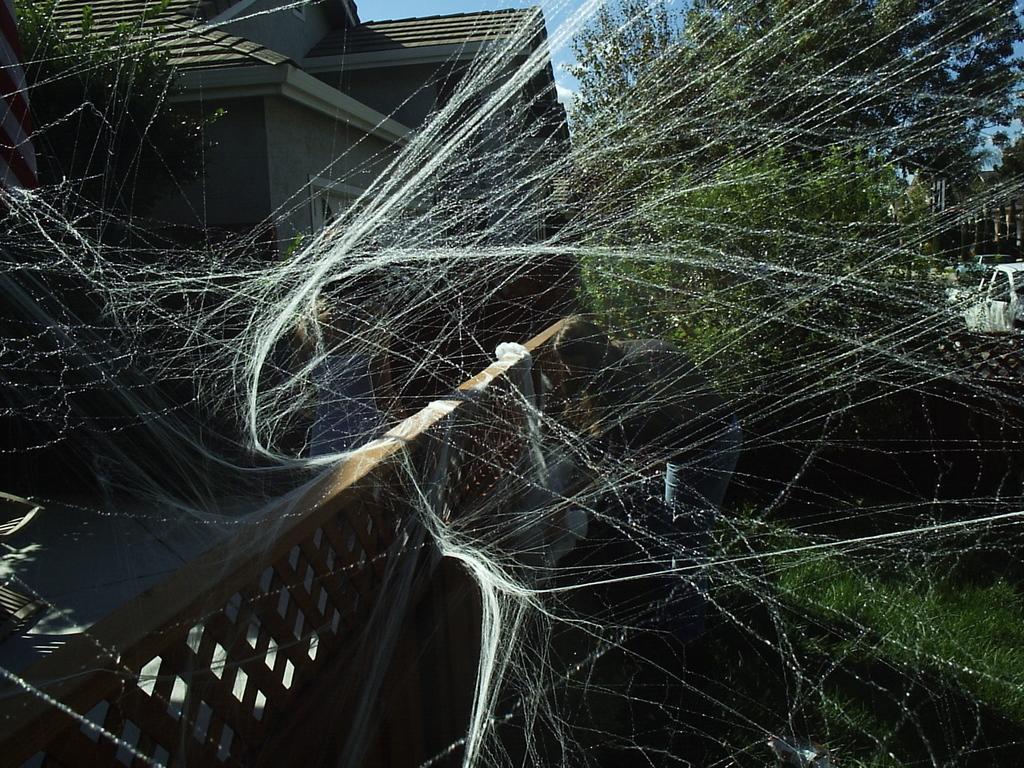How would you summarize this image in a sentence or two? In this image there is house on the left side. On the left side bottom there is a wooden fence on which there is a spider web. In the background there are trees. 